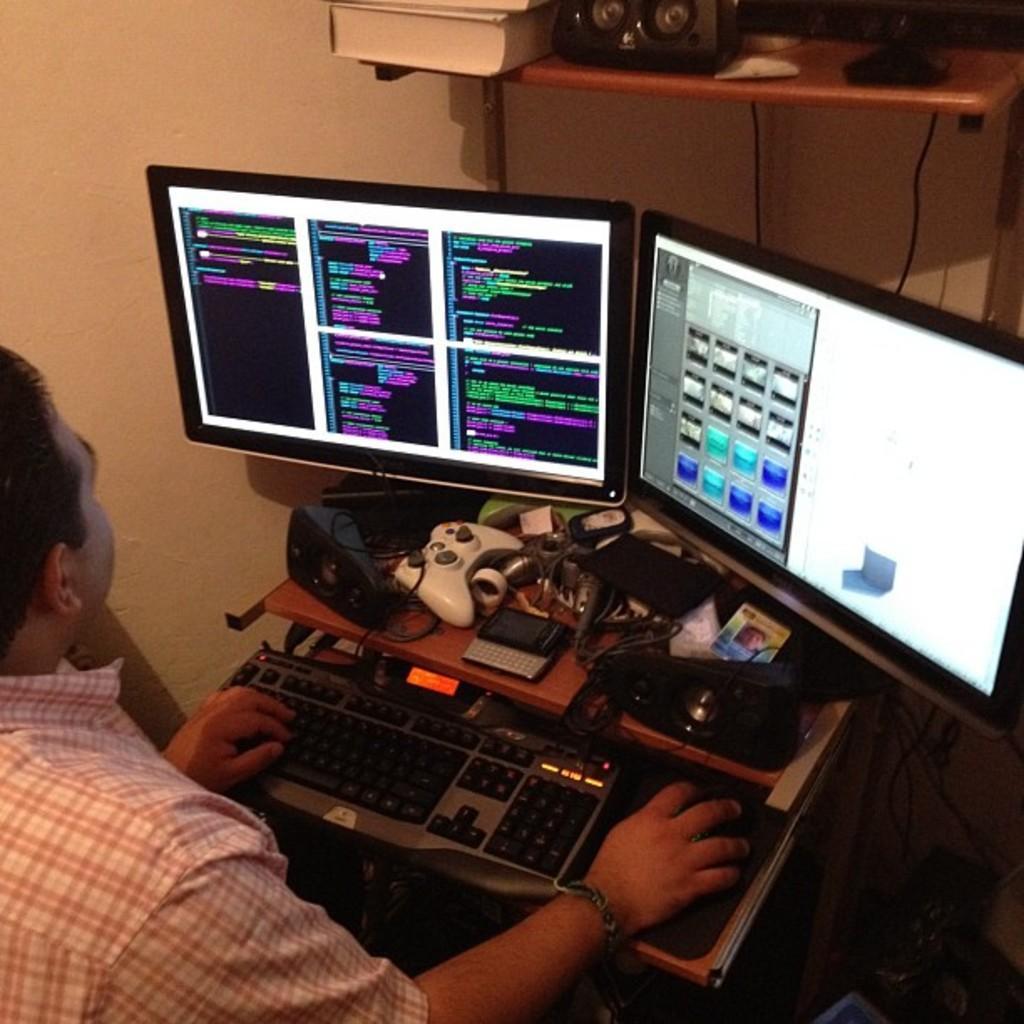Please provide a concise description of this image. In the center of the image we can see a table. On the table we can see a keyboard, mouse, CD, video player game, screens and some other objects. On the left side of the image we can see a man is sitting and holding a mouse and operating the systems. In the background of the image we can see the wall, shelf, book, wire and other objects. 